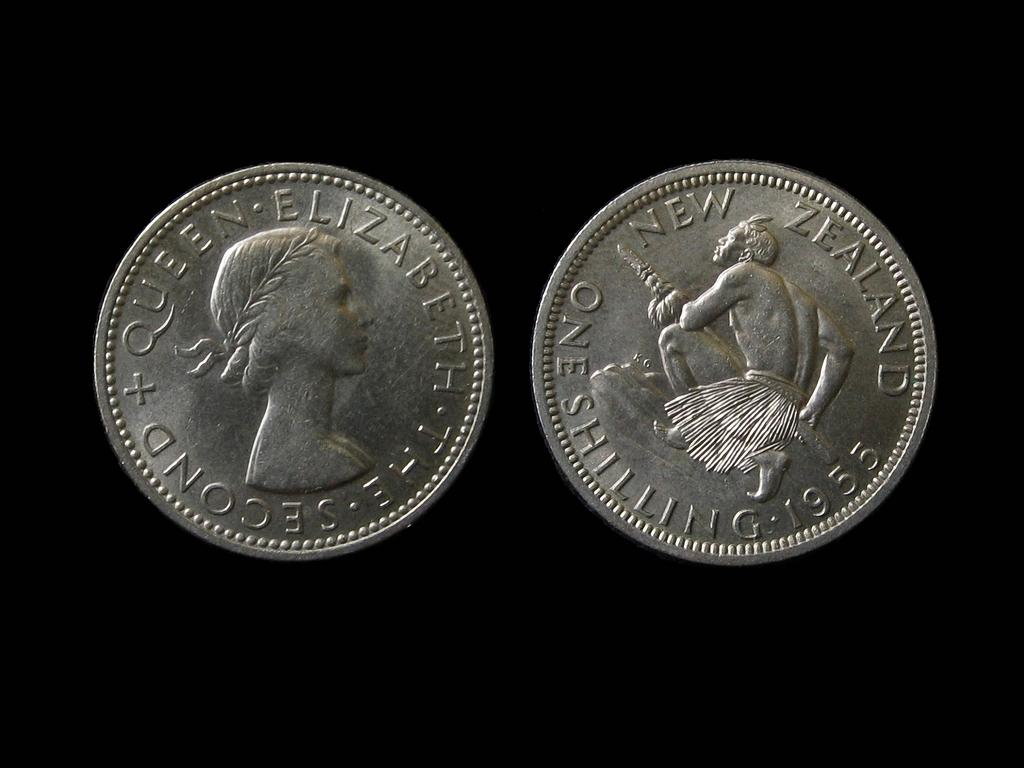<image>
Provide a brief description of the given image. Two silver coins, the one on the right from New Zealand in 1955. 